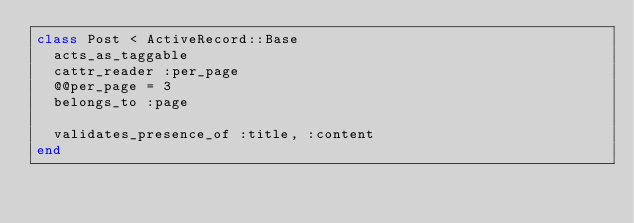Convert code to text. <code><loc_0><loc_0><loc_500><loc_500><_Ruby_>class Post < ActiveRecord::Base
  acts_as_taggable
  cattr_reader :per_page
  @@per_page = 3
  belongs_to :page
  
  validates_presence_of :title, :content
end
</code> 